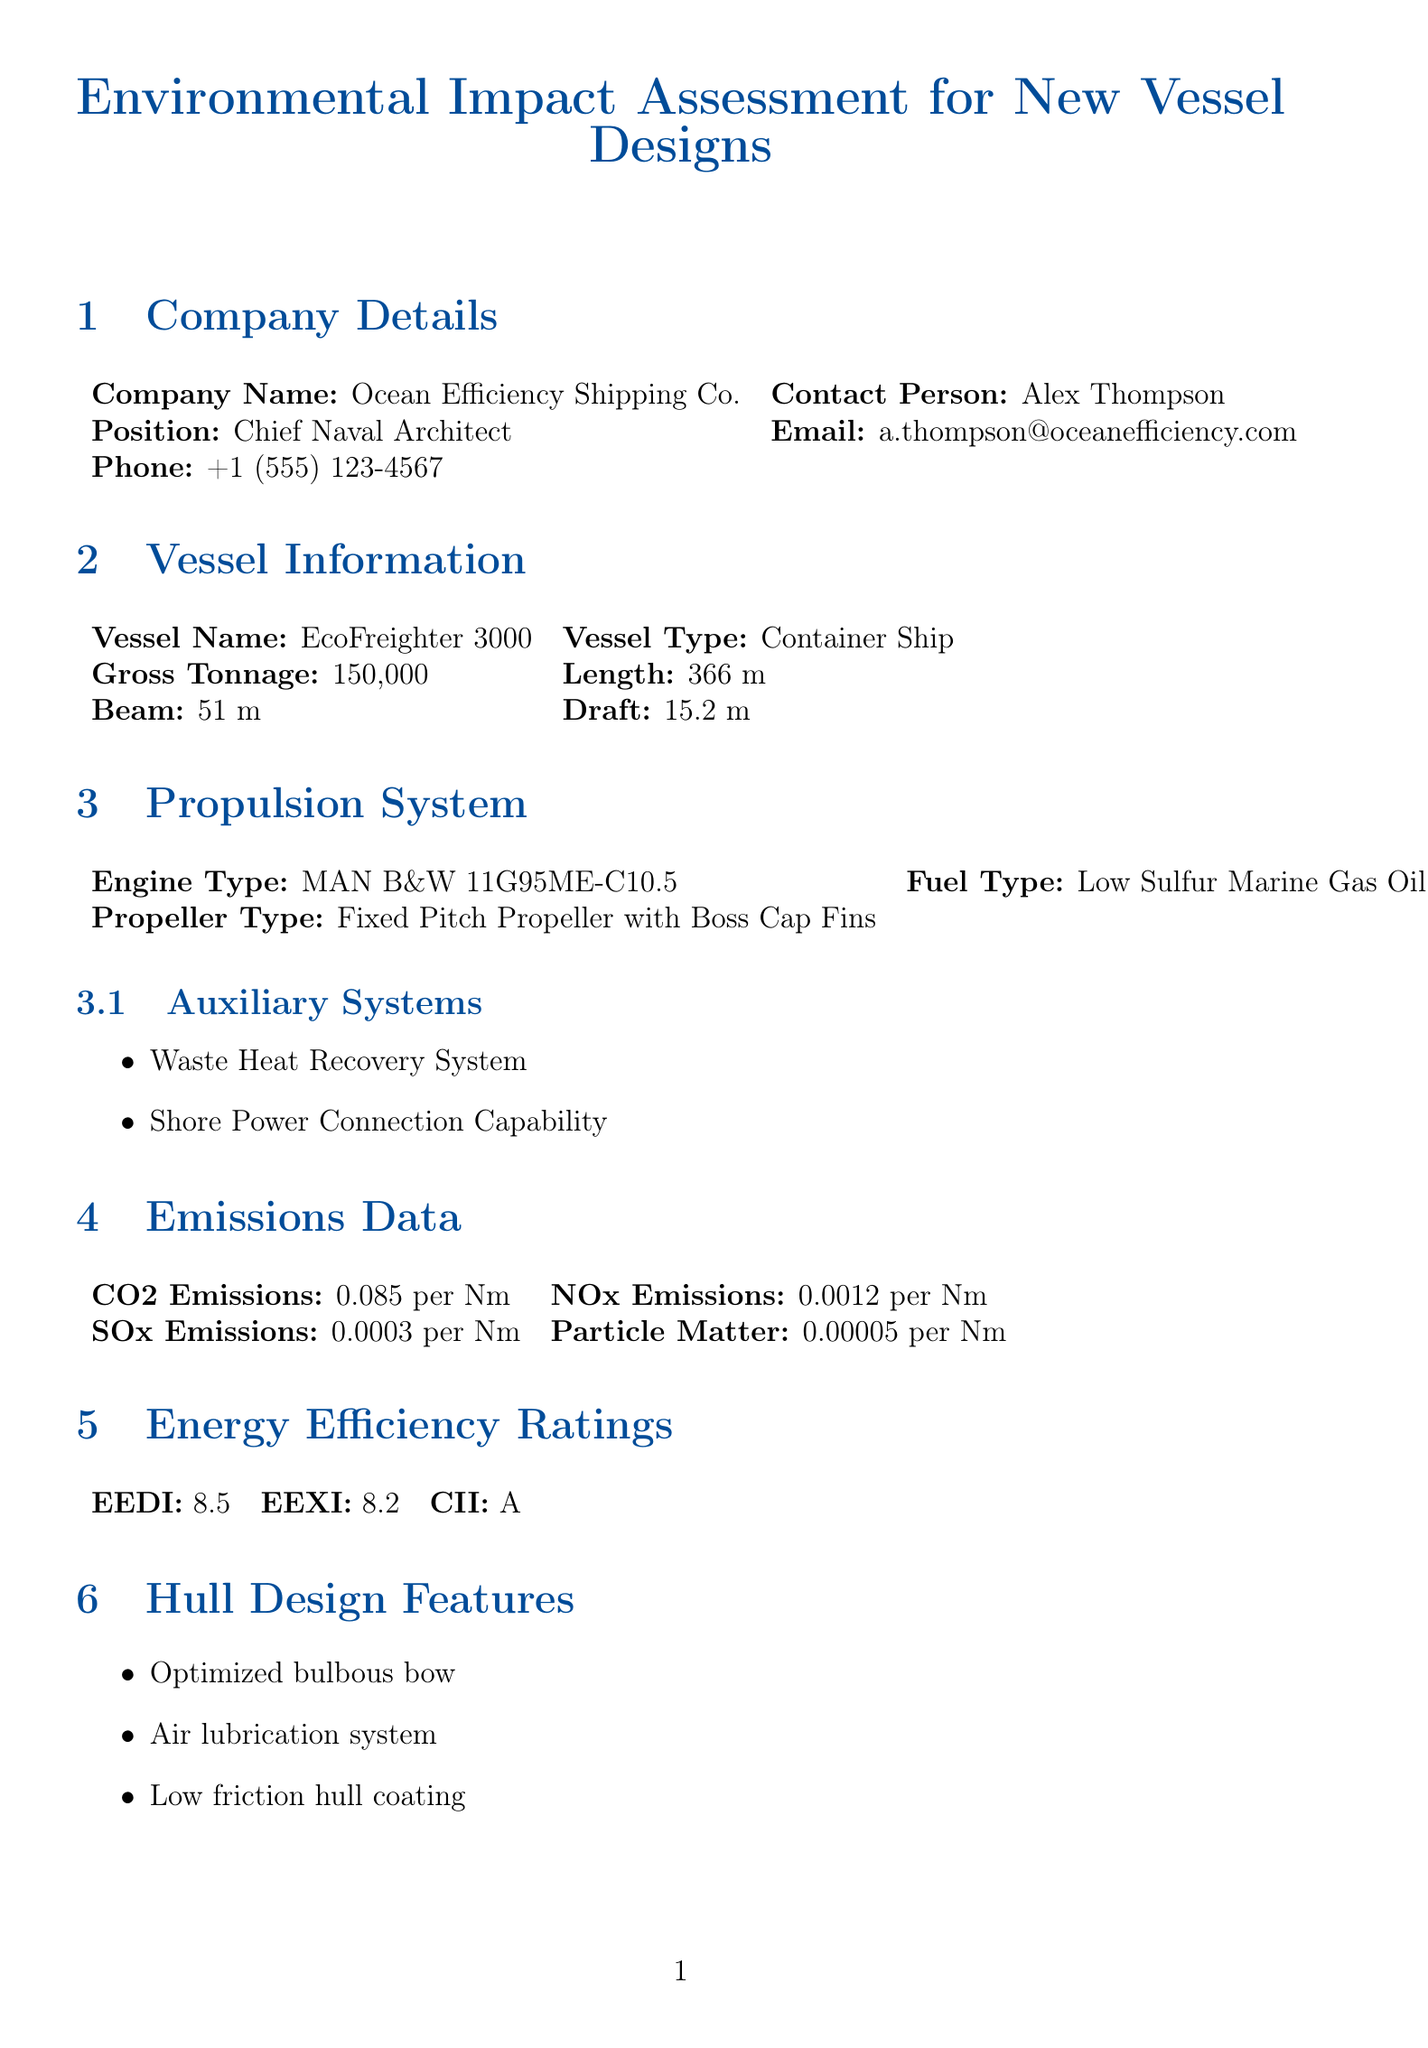What is the vessel name? The vessel name is provided in the vessel information section of the document.
Answer: EcoFreighter 3000 What is the gross tonnage of the vessel? Gross tonnage is specified in the vessel information section.
Answer: 150,000 What type of engine is used in the propulsion system? The engine type is mentioned under the propulsion system section.
Answer: MAN B&W 11G95ME-C10.5 What are the CO2 emissions per nautical mile? CO2 emissions per nautical mile is listed in the emissions data section.
Answer: 0.085 per Nm What is the EEDI rating for the vessel? The Energy Efficiency Design Index rating is stated in the energy efficiency ratings section.
Answer: 8.5 What system is mentioned for cargo hold layout optimization? The cargo hold layout optimization system is indicated in the cargo capacity optimization section.
Answer: Cell-guide system for faster loading/unloading How long is the expected lifespan of the vessel? The expected lifespan is provided in the lifecycle section of the document.
Answer: 25 years Which renewable energy technology is integrated into the vessel? The renewable energy integration section lists specific technology used.
Answer: Solar Panels What is the maintenance cost reduction percentage expected? The maintenance cost reduction is part of the economic impact section.
Answer: 10% What is the classification society for this vessel? The classification society is specified in the compliance information section.
Answer: DNV GL 